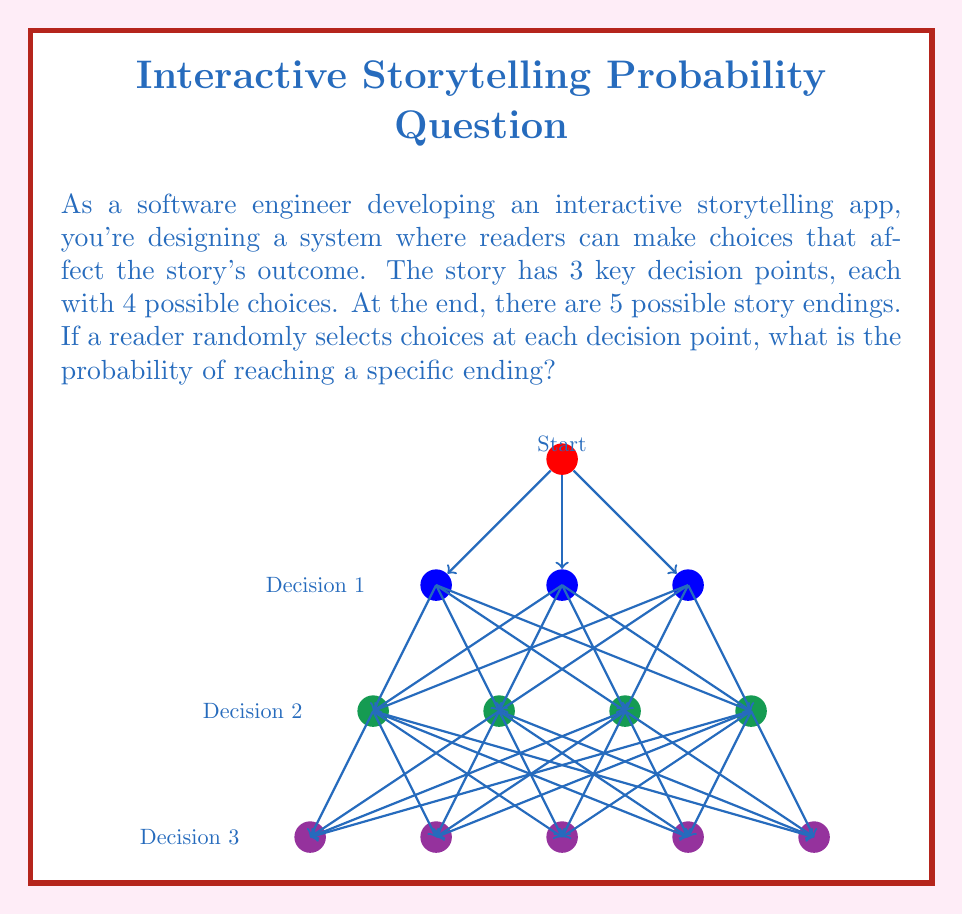Can you answer this question? Let's approach this step-by-step:

1) First, we need to calculate the total number of possible paths through the story:
   - At each decision point, there are 4 choices
   - There are 3 decision points
   - Total number of paths = $4 \times 4 \times 4 = 4^3 = 64$

2) Now, we need to consider how many of these paths lead to each ending:
   - There are 5 possible endings
   - If the paths were evenly distributed (which they may not be in a real story), each ending would have $\frac{64}{5} = 12.8$ paths leading to it

3) However, we're asked about the probability of reaching a specific ending. In a uniformly random selection, this would be:
   
   $$P(\text{specific ending}) = \frac{\text{Number of favorable outcomes}}{\text{Total number of possible outcomes}} = \frac{1}{5} = 0.2$$

4) This probability can be derived another way:
   - At each decision point, the probability of choosing any particular option is $\frac{1}{4}$
   - The probability of a specific path is thus $\frac{1}{4} \times \frac{1}{4} \times \frac{1}{4} = (\frac{1}{4})^3 = \frac{1}{64}$
   - If there are indeed 12.8 paths to each ending (rounding to 13 for simplicity), the probability would be $13 \times \frac{1}{64} \approx 0.203125$

5) The exact probability might vary slightly depending on how the paths are actually distributed among the endings, but assuming a uniform distribution, the probability remains $\frac{1}{5}$ or 0.2.
Answer: $\frac{1}{5}$ or 0.2 